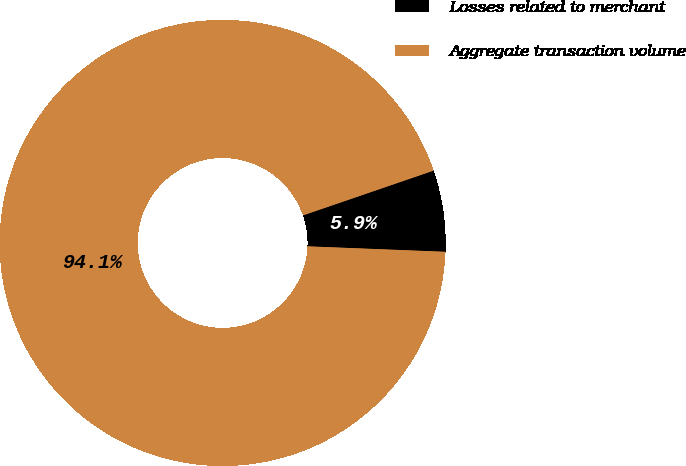Convert chart. <chart><loc_0><loc_0><loc_500><loc_500><pie_chart><fcel>Losses related to merchant<fcel>Aggregate transaction volume<nl><fcel>5.89%<fcel>94.11%<nl></chart> 